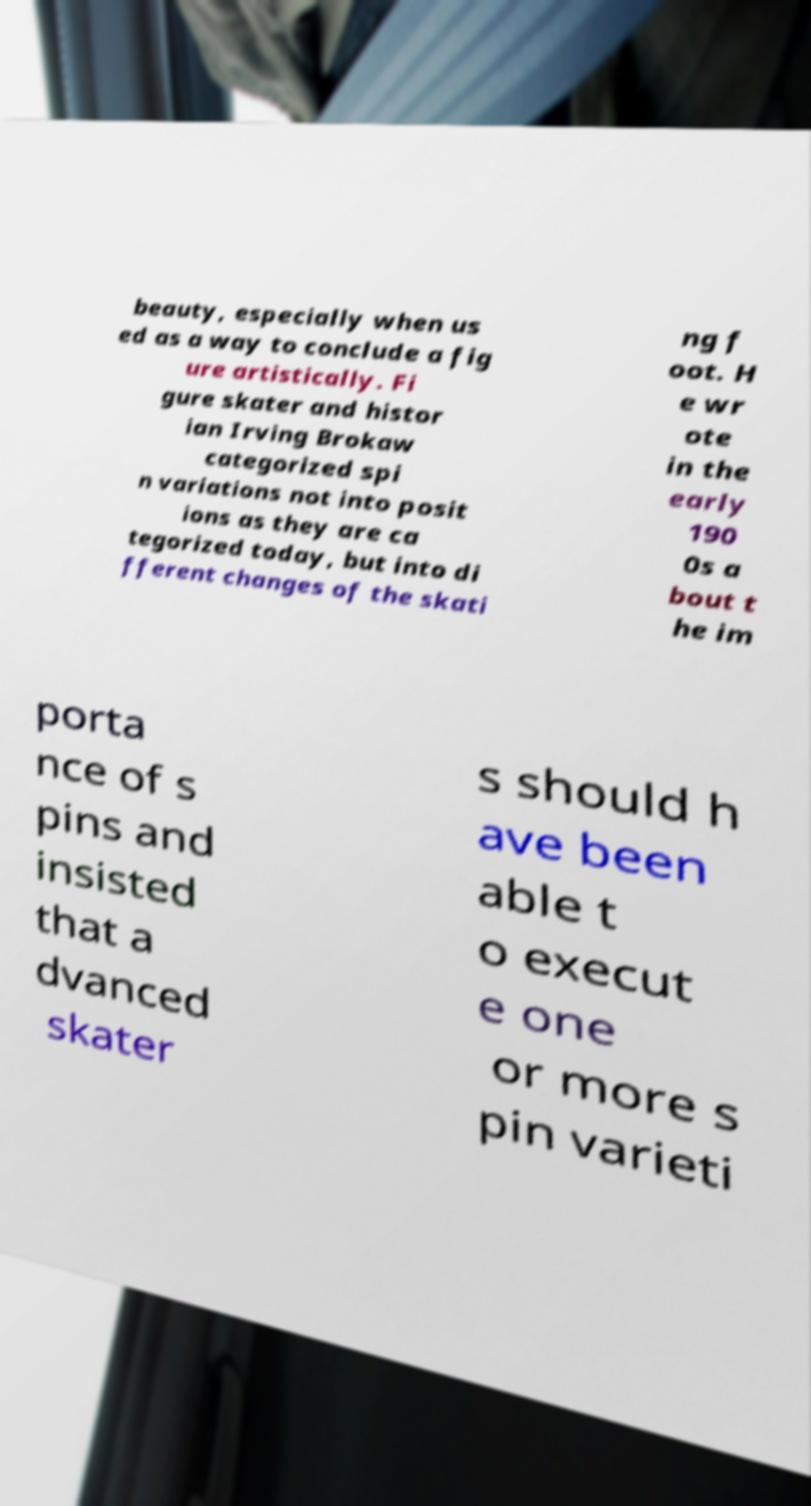What messages or text are displayed in this image? I need them in a readable, typed format. beauty, especially when us ed as a way to conclude a fig ure artistically. Fi gure skater and histor ian Irving Brokaw categorized spi n variations not into posit ions as they are ca tegorized today, but into di fferent changes of the skati ng f oot. H e wr ote in the early 190 0s a bout t he im porta nce of s pins and insisted that a dvanced skater s should h ave been able t o execut e one or more s pin varieti 